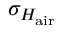<formula> <loc_0><loc_0><loc_500><loc_500>\sigma _ { H _ { a i r } }</formula> 